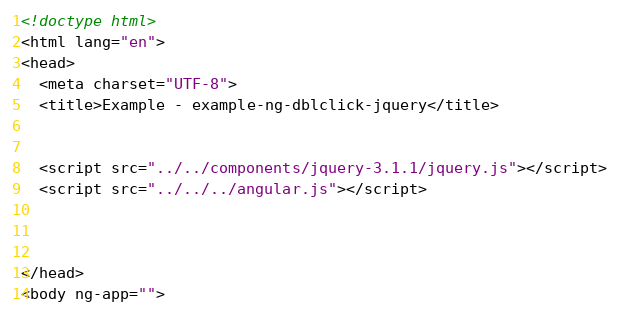<code> <loc_0><loc_0><loc_500><loc_500><_HTML_><!doctype html>
<html lang="en">
<head>
  <meta charset="UTF-8">
  <title>Example - example-ng-dblclick-jquery</title>
  

  <script src="../../components/jquery-3.1.1/jquery.js"></script>
  <script src="../../../angular.js"></script>
  

  
</head>
<body ng-app=""></code> 